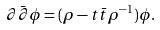<formula> <loc_0><loc_0><loc_500><loc_500>\partial \bar { \partial } \phi = ( \rho - t \bar { t } \rho ^ { - 1 } ) \phi .</formula> 